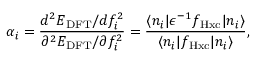Convert formula to latex. <formula><loc_0><loc_0><loc_500><loc_500>\alpha _ { i } = \frac { d ^ { 2 } E _ { D F T } / d f _ { i } ^ { 2 } } { \partial ^ { 2 } E _ { D F T } / \partial f _ { i } ^ { 2 } } = \frac { \langle n _ { i } | \epsilon ^ { - 1 } f _ { H x c } | n _ { i } \rangle } { \langle n _ { i } | f _ { H x c } | n _ { i } \rangle } ,</formula> 